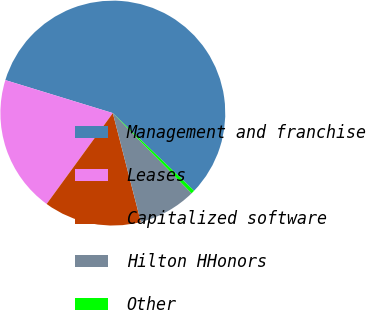<chart> <loc_0><loc_0><loc_500><loc_500><pie_chart><fcel>Management and franchise<fcel>Leases<fcel>Capitalized software<fcel>Hilton HHonors<fcel>Other<nl><fcel>57.4%<fcel>19.72%<fcel>14.03%<fcel>8.34%<fcel>0.5%<nl></chart> 